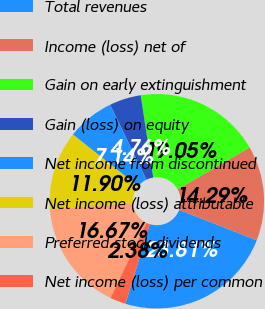Convert chart. <chart><loc_0><loc_0><loc_500><loc_500><pie_chart><fcel>Total revenues<fcel>Income (loss) net of<fcel>Gain on early extinguishment<fcel>Gain (loss) on equity<fcel>Net income from discontinued<fcel>Net income (loss) attributable<fcel>Preferred stock dividends<fcel>Net income (loss) per common<nl><fcel>23.81%<fcel>14.29%<fcel>19.05%<fcel>4.76%<fcel>7.14%<fcel>11.9%<fcel>16.67%<fcel>2.38%<nl></chart> 